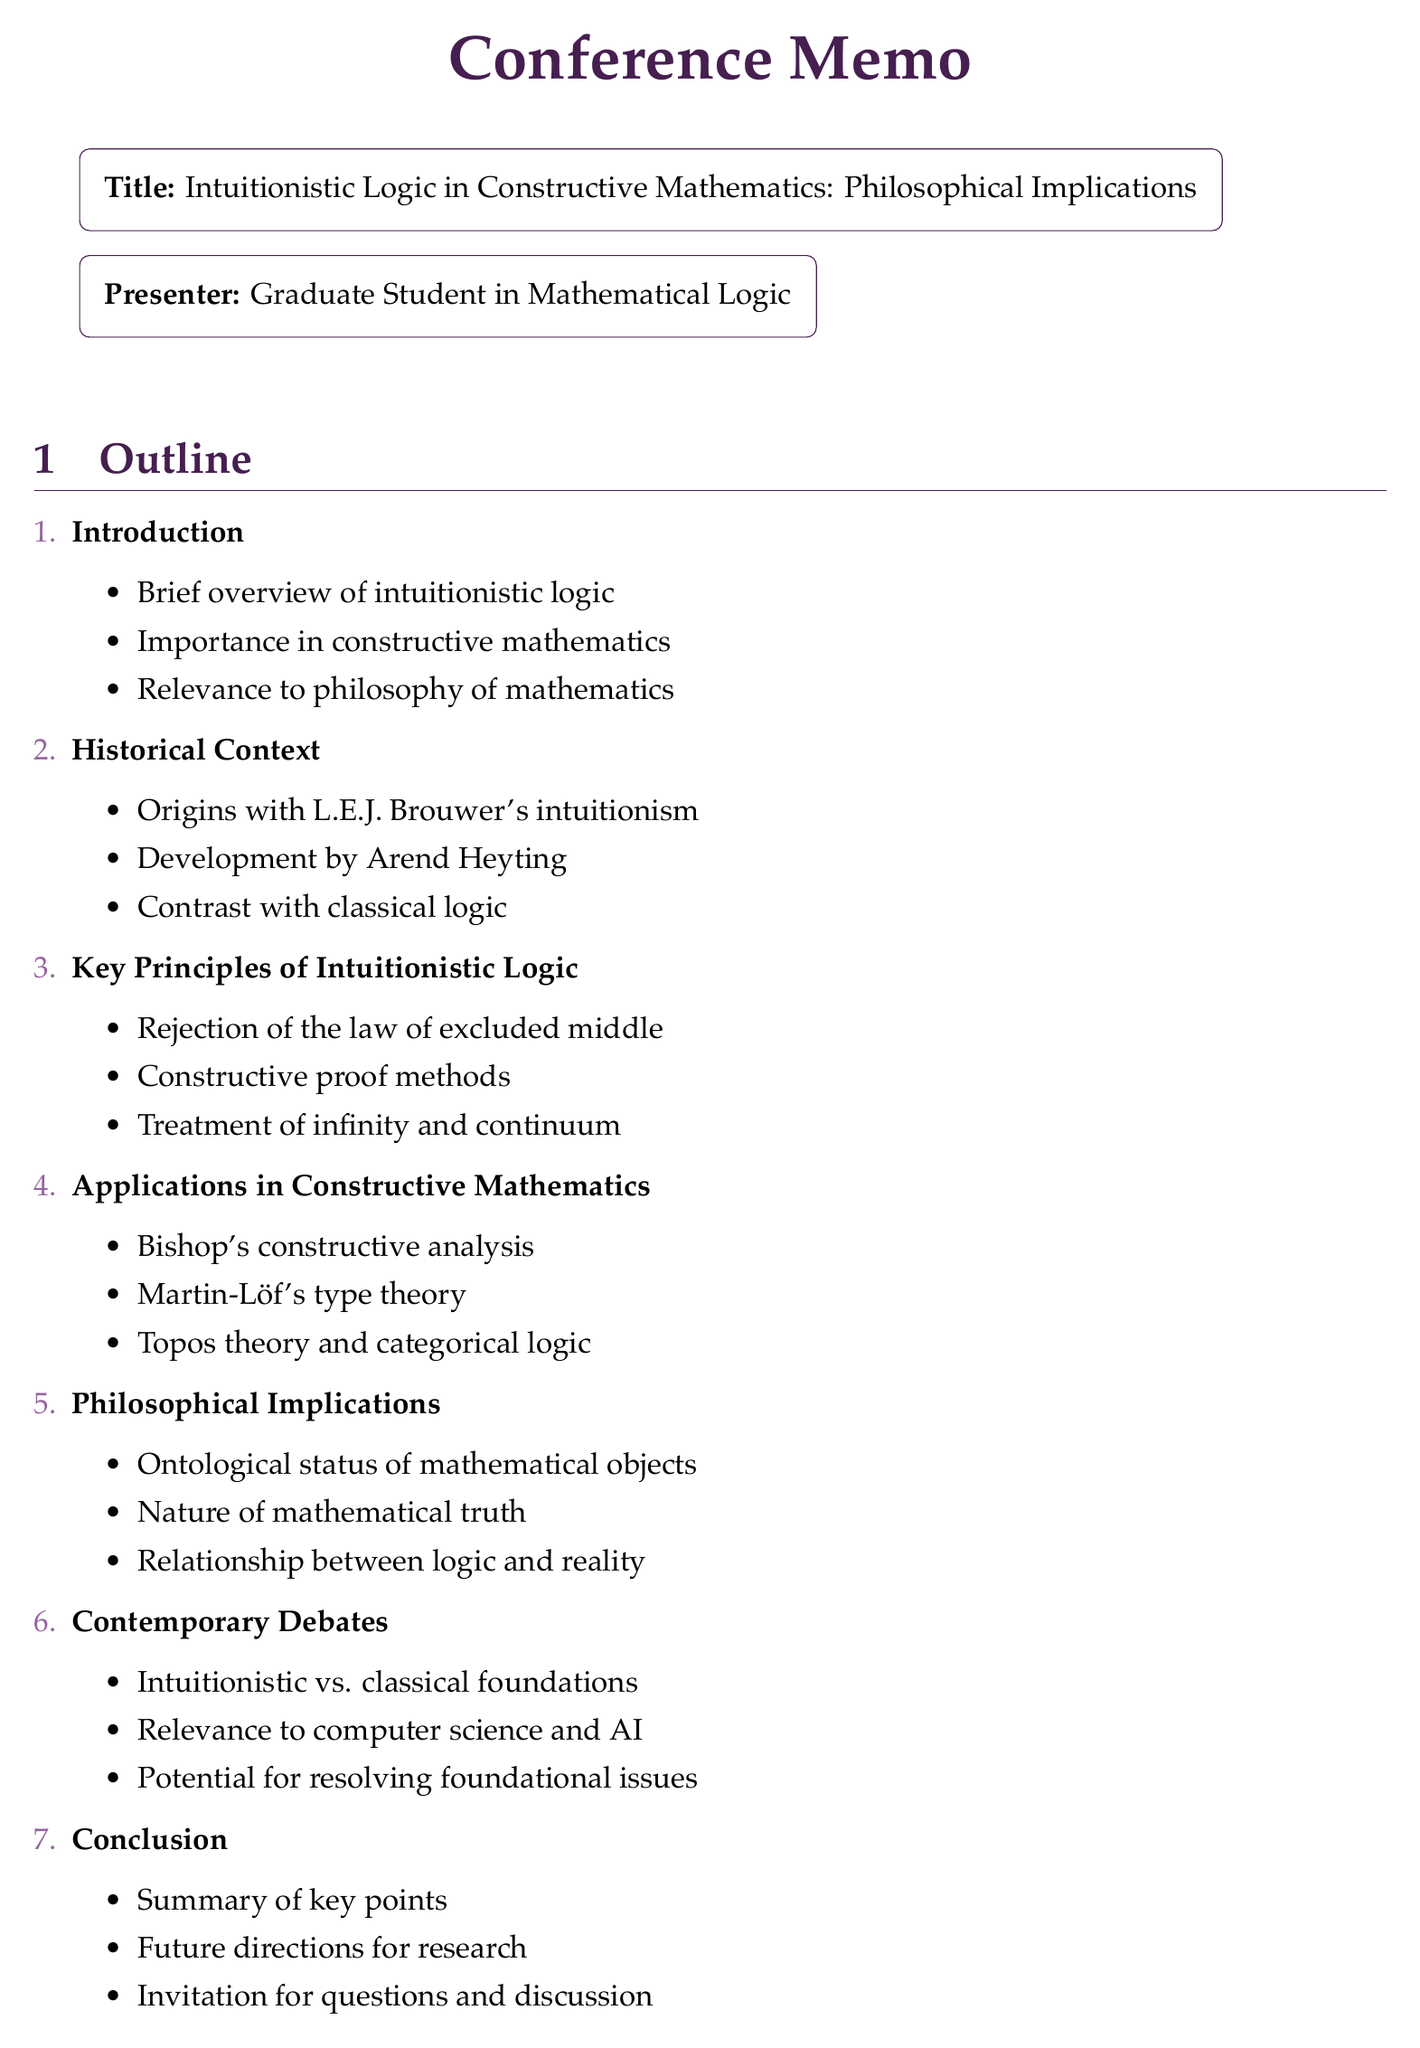What is the title of the conference? The title of the conference is clearly stated in the document as "Intuitionistic Logic in Constructive Mathematics: Philosophical Implications."
Answer: Intuitionistic Logic in Constructive Mathematics: Philosophical Implications Who is the presenter? The document lists the presenter as "Graduate Student in Mathematical Logic."
Answer: Graduate Student in Mathematical Logic What year was "Elements of Intuitionism" published? The document provides the publication year for "Elements of Intuitionism" as 2000.
Answer: 2000 Name one key principle of intuitionistic logic. One key principle mentioned in the document is the "Rejection of the law of excluded middle."
Answer: Rejection of the law of excluded middle Which philosopher is associated with the origins of intuitionism? The document states that "L.E.J. Brouwer" is associated with the origins of intuitionism.
Answer: L.E.J. Brouwer What is the focus of the philosophical implications section? The section covers topics including "Ontological status of mathematical objects," which is a focus in the document.
Answer: Ontological status of mathematical objects What does the conclusion section invite? The conclusion section includes an "Invitation for questions and discussion."
Answer: Invitation for questions and discussion How many sections are in the outline? The document outlines a total of seven sections, as indicated by the structure of the outline.
Answer: Seven sections 